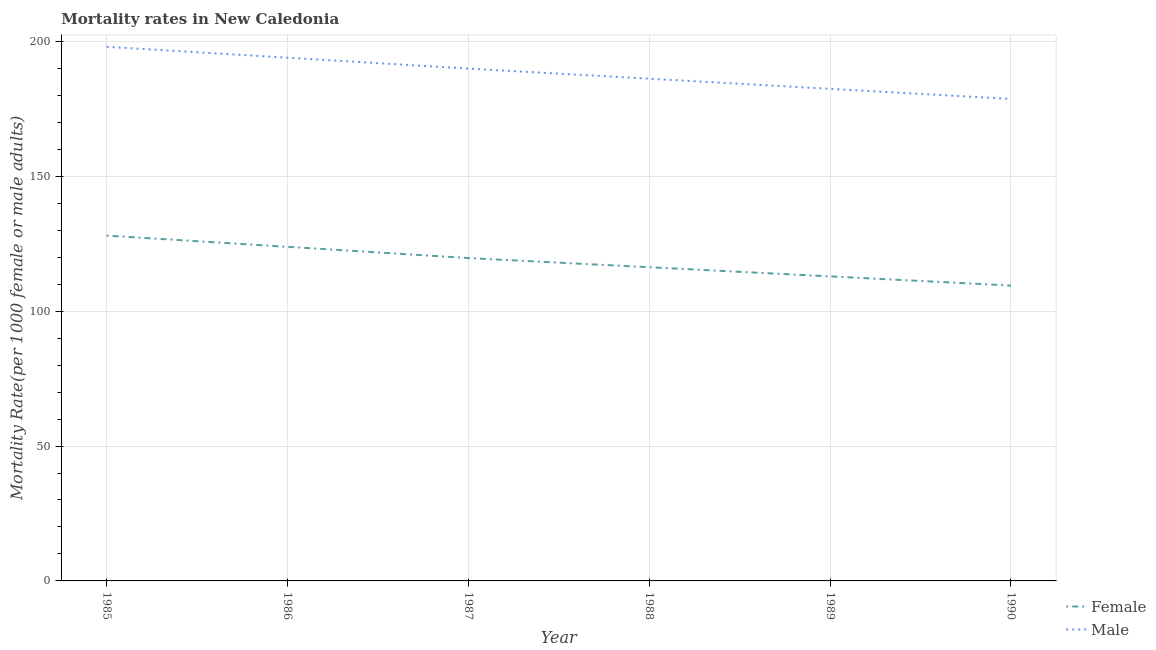What is the female mortality rate in 1990?
Give a very brief answer. 109.49. Across all years, what is the maximum male mortality rate?
Your answer should be compact. 198. Across all years, what is the minimum male mortality rate?
Make the answer very short. 178.67. In which year was the male mortality rate maximum?
Offer a terse response. 1985. What is the total female mortality rate in the graph?
Your answer should be very brief. 710.22. What is the difference between the female mortality rate in 1989 and that in 1990?
Your answer should be compact. 3.4. What is the difference between the male mortality rate in 1985 and the female mortality rate in 1986?
Your answer should be very brief. 74.14. What is the average female mortality rate per year?
Provide a short and direct response. 118.37. In the year 1989, what is the difference between the male mortality rate and female mortality rate?
Your answer should be very brief. 69.53. In how many years, is the female mortality rate greater than 190?
Provide a short and direct response. 0. What is the ratio of the female mortality rate in 1985 to that in 1986?
Make the answer very short. 1.03. Is the difference between the female mortality rate in 1987 and 1990 greater than the difference between the male mortality rate in 1987 and 1990?
Give a very brief answer. No. What is the difference between the highest and the second highest male mortality rate?
Your answer should be very brief. 4.04. What is the difference between the highest and the lowest female mortality rate?
Your response must be concise. 18.53. Is the female mortality rate strictly greater than the male mortality rate over the years?
Offer a terse response. No. Is the female mortality rate strictly less than the male mortality rate over the years?
Your answer should be very brief. Yes. What is the difference between two consecutive major ticks on the Y-axis?
Your answer should be very brief. 50. Where does the legend appear in the graph?
Offer a very short reply. Bottom right. How many legend labels are there?
Offer a very short reply. 2. How are the legend labels stacked?
Offer a terse response. Vertical. What is the title of the graph?
Your answer should be very brief. Mortality rates in New Caledonia. What is the label or title of the Y-axis?
Keep it short and to the point. Mortality Rate(per 1000 female or male adults). What is the Mortality Rate(per 1000 female or male adults) of Female in 1985?
Your answer should be compact. 128.02. What is the Mortality Rate(per 1000 female or male adults) in Male in 1985?
Give a very brief answer. 198. What is the Mortality Rate(per 1000 female or male adults) in Female in 1986?
Keep it short and to the point. 123.85. What is the Mortality Rate(per 1000 female or male adults) in Male in 1986?
Provide a succinct answer. 193.96. What is the Mortality Rate(per 1000 female or male adults) of Female in 1987?
Your response must be concise. 119.69. What is the Mortality Rate(per 1000 female or male adults) in Male in 1987?
Your answer should be very brief. 189.92. What is the Mortality Rate(per 1000 female or male adults) of Female in 1988?
Offer a terse response. 116.29. What is the Mortality Rate(per 1000 female or male adults) in Male in 1988?
Give a very brief answer. 186.17. What is the Mortality Rate(per 1000 female or male adults) of Female in 1989?
Your answer should be compact. 112.89. What is the Mortality Rate(per 1000 female or male adults) in Male in 1989?
Offer a terse response. 182.42. What is the Mortality Rate(per 1000 female or male adults) in Female in 1990?
Provide a short and direct response. 109.49. What is the Mortality Rate(per 1000 female or male adults) of Male in 1990?
Your response must be concise. 178.67. Across all years, what is the maximum Mortality Rate(per 1000 female or male adults) in Female?
Ensure brevity in your answer.  128.02. Across all years, what is the maximum Mortality Rate(per 1000 female or male adults) of Male?
Make the answer very short. 198. Across all years, what is the minimum Mortality Rate(per 1000 female or male adults) of Female?
Make the answer very short. 109.49. Across all years, what is the minimum Mortality Rate(per 1000 female or male adults) in Male?
Offer a terse response. 178.67. What is the total Mortality Rate(per 1000 female or male adults) in Female in the graph?
Give a very brief answer. 710.22. What is the total Mortality Rate(per 1000 female or male adults) in Male in the graph?
Provide a short and direct response. 1129.14. What is the difference between the Mortality Rate(per 1000 female or male adults) in Female in 1985 and that in 1986?
Make the answer very short. 4.17. What is the difference between the Mortality Rate(per 1000 female or male adults) of Male in 1985 and that in 1986?
Offer a terse response. 4.04. What is the difference between the Mortality Rate(per 1000 female or male adults) in Female in 1985 and that in 1987?
Provide a succinct answer. 8.33. What is the difference between the Mortality Rate(per 1000 female or male adults) in Male in 1985 and that in 1987?
Your answer should be compact. 8.07. What is the difference between the Mortality Rate(per 1000 female or male adults) of Female in 1985 and that in 1988?
Provide a short and direct response. 11.73. What is the difference between the Mortality Rate(per 1000 female or male adults) of Male in 1985 and that in 1988?
Ensure brevity in your answer.  11.82. What is the difference between the Mortality Rate(per 1000 female or male adults) of Female in 1985 and that in 1989?
Offer a terse response. 15.13. What is the difference between the Mortality Rate(per 1000 female or male adults) in Male in 1985 and that in 1989?
Your answer should be very brief. 15.58. What is the difference between the Mortality Rate(per 1000 female or male adults) of Female in 1985 and that in 1990?
Your response must be concise. 18.53. What is the difference between the Mortality Rate(per 1000 female or male adults) in Male in 1985 and that in 1990?
Give a very brief answer. 19.33. What is the difference between the Mortality Rate(per 1000 female or male adults) of Female in 1986 and that in 1987?
Offer a very short reply. 4.17. What is the difference between the Mortality Rate(per 1000 female or male adults) of Male in 1986 and that in 1987?
Offer a very short reply. 4.04. What is the difference between the Mortality Rate(per 1000 female or male adults) in Female in 1986 and that in 1988?
Offer a terse response. 7.56. What is the difference between the Mortality Rate(per 1000 female or male adults) of Male in 1986 and that in 1988?
Provide a short and direct response. 7.79. What is the difference between the Mortality Rate(per 1000 female or male adults) in Female in 1986 and that in 1989?
Your answer should be very brief. 10.96. What is the difference between the Mortality Rate(per 1000 female or male adults) in Male in 1986 and that in 1989?
Offer a terse response. 11.54. What is the difference between the Mortality Rate(per 1000 female or male adults) of Female in 1986 and that in 1990?
Provide a succinct answer. 14.36. What is the difference between the Mortality Rate(per 1000 female or male adults) in Male in 1986 and that in 1990?
Ensure brevity in your answer.  15.29. What is the difference between the Mortality Rate(per 1000 female or male adults) in Female in 1987 and that in 1988?
Your answer should be compact. 3.4. What is the difference between the Mortality Rate(per 1000 female or male adults) in Male in 1987 and that in 1988?
Your response must be concise. 3.75. What is the difference between the Mortality Rate(per 1000 female or male adults) of Female in 1987 and that in 1989?
Offer a terse response. 6.8. What is the difference between the Mortality Rate(per 1000 female or male adults) of Male in 1987 and that in 1989?
Provide a short and direct response. 7.5. What is the difference between the Mortality Rate(per 1000 female or male adults) of Female in 1987 and that in 1990?
Make the answer very short. 10.19. What is the difference between the Mortality Rate(per 1000 female or male adults) in Male in 1987 and that in 1990?
Your answer should be very brief. 11.26. What is the difference between the Mortality Rate(per 1000 female or male adults) of Female in 1988 and that in 1989?
Offer a very short reply. 3.4. What is the difference between the Mortality Rate(per 1000 female or male adults) of Male in 1988 and that in 1989?
Your answer should be very brief. 3.75. What is the difference between the Mortality Rate(per 1000 female or male adults) of Female in 1988 and that in 1990?
Ensure brevity in your answer.  6.8. What is the difference between the Mortality Rate(per 1000 female or male adults) of Male in 1988 and that in 1990?
Your answer should be compact. 7.5. What is the difference between the Mortality Rate(per 1000 female or male adults) in Female in 1989 and that in 1990?
Your answer should be compact. 3.4. What is the difference between the Mortality Rate(per 1000 female or male adults) in Male in 1989 and that in 1990?
Give a very brief answer. 3.75. What is the difference between the Mortality Rate(per 1000 female or male adults) of Female in 1985 and the Mortality Rate(per 1000 female or male adults) of Male in 1986?
Your response must be concise. -65.94. What is the difference between the Mortality Rate(per 1000 female or male adults) in Female in 1985 and the Mortality Rate(per 1000 female or male adults) in Male in 1987?
Offer a terse response. -61.91. What is the difference between the Mortality Rate(per 1000 female or male adults) in Female in 1985 and the Mortality Rate(per 1000 female or male adults) in Male in 1988?
Provide a short and direct response. -58.15. What is the difference between the Mortality Rate(per 1000 female or male adults) of Female in 1985 and the Mortality Rate(per 1000 female or male adults) of Male in 1989?
Your answer should be compact. -54.4. What is the difference between the Mortality Rate(per 1000 female or male adults) of Female in 1985 and the Mortality Rate(per 1000 female or male adults) of Male in 1990?
Make the answer very short. -50.65. What is the difference between the Mortality Rate(per 1000 female or male adults) of Female in 1986 and the Mortality Rate(per 1000 female or male adults) of Male in 1987?
Offer a very short reply. -66.07. What is the difference between the Mortality Rate(per 1000 female or male adults) in Female in 1986 and the Mortality Rate(per 1000 female or male adults) in Male in 1988?
Your response must be concise. -62.32. What is the difference between the Mortality Rate(per 1000 female or male adults) of Female in 1986 and the Mortality Rate(per 1000 female or male adults) of Male in 1989?
Your response must be concise. -58.57. What is the difference between the Mortality Rate(per 1000 female or male adults) of Female in 1986 and the Mortality Rate(per 1000 female or male adults) of Male in 1990?
Provide a succinct answer. -54.82. What is the difference between the Mortality Rate(per 1000 female or male adults) in Female in 1987 and the Mortality Rate(per 1000 female or male adults) in Male in 1988?
Ensure brevity in your answer.  -66.49. What is the difference between the Mortality Rate(per 1000 female or male adults) in Female in 1987 and the Mortality Rate(per 1000 female or male adults) in Male in 1989?
Your answer should be compact. -62.73. What is the difference between the Mortality Rate(per 1000 female or male adults) of Female in 1987 and the Mortality Rate(per 1000 female or male adults) of Male in 1990?
Offer a terse response. -58.98. What is the difference between the Mortality Rate(per 1000 female or male adults) of Female in 1988 and the Mortality Rate(per 1000 female or male adults) of Male in 1989?
Give a very brief answer. -66.13. What is the difference between the Mortality Rate(per 1000 female or male adults) in Female in 1988 and the Mortality Rate(per 1000 female or male adults) in Male in 1990?
Provide a succinct answer. -62.38. What is the difference between the Mortality Rate(per 1000 female or male adults) of Female in 1989 and the Mortality Rate(per 1000 female or male adults) of Male in 1990?
Give a very brief answer. -65.78. What is the average Mortality Rate(per 1000 female or male adults) of Female per year?
Provide a short and direct response. 118.37. What is the average Mortality Rate(per 1000 female or male adults) of Male per year?
Give a very brief answer. 188.19. In the year 1985, what is the difference between the Mortality Rate(per 1000 female or male adults) of Female and Mortality Rate(per 1000 female or male adults) of Male?
Offer a very short reply. -69.98. In the year 1986, what is the difference between the Mortality Rate(per 1000 female or male adults) of Female and Mortality Rate(per 1000 female or male adults) of Male?
Your answer should be compact. -70.11. In the year 1987, what is the difference between the Mortality Rate(per 1000 female or male adults) of Female and Mortality Rate(per 1000 female or male adults) of Male?
Your response must be concise. -70.24. In the year 1988, what is the difference between the Mortality Rate(per 1000 female or male adults) in Female and Mortality Rate(per 1000 female or male adults) in Male?
Provide a short and direct response. -69.88. In the year 1989, what is the difference between the Mortality Rate(per 1000 female or male adults) in Female and Mortality Rate(per 1000 female or male adults) in Male?
Keep it short and to the point. -69.53. In the year 1990, what is the difference between the Mortality Rate(per 1000 female or male adults) in Female and Mortality Rate(per 1000 female or male adults) in Male?
Your response must be concise. -69.18. What is the ratio of the Mortality Rate(per 1000 female or male adults) in Female in 1985 to that in 1986?
Offer a terse response. 1.03. What is the ratio of the Mortality Rate(per 1000 female or male adults) of Male in 1985 to that in 1986?
Offer a terse response. 1.02. What is the ratio of the Mortality Rate(per 1000 female or male adults) of Female in 1985 to that in 1987?
Offer a very short reply. 1.07. What is the ratio of the Mortality Rate(per 1000 female or male adults) of Male in 1985 to that in 1987?
Offer a very short reply. 1.04. What is the ratio of the Mortality Rate(per 1000 female or male adults) of Female in 1985 to that in 1988?
Make the answer very short. 1.1. What is the ratio of the Mortality Rate(per 1000 female or male adults) in Male in 1985 to that in 1988?
Offer a terse response. 1.06. What is the ratio of the Mortality Rate(per 1000 female or male adults) in Female in 1985 to that in 1989?
Offer a terse response. 1.13. What is the ratio of the Mortality Rate(per 1000 female or male adults) of Male in 1985 to that in 1989?
Provide a short and direct response. 1.09. What is the ratio of the Mortality Rate(per 1000 female or male adults) of Female in 1985 to that in 1990?
Make the answer very short. 1.17. What is the ratio of the Mortality Rate(per 1000 female or male adults) in Male in 1985 to that in 1990?
Offer a very short reply. 1.11. What is the ratio of the Mortality Rate(per 1000 female or male adults) of Female in 1986 to that in 1987?
Provide a succinct answer. 1.03. What is the ratio of the Mortality Rate(per 1000 female or male adults) of Male in 1986 to that in 1987?
Your response must be concise. 1.02. What is the ratio of the Mortality Rate(per 1000 female or male adults) of Female in 1986 to that in 1988?
Make the answer very short. 1.06. What is the ratio of the Mortality Rate(per 1000 female or male adults) of Male in 1986 to that in 1988?
Your answer should be compact. 1.04. What is the ratio of the Mortality Rate(per 1000 female or male adults) in Female in 1986 to that in 1989?
Offer a very short reply. 1.1. What is the ratio of the Mortality Rate(per 1000 female or male adults) of Male in 1986 to that in 1989?
Ensure brevity in your answer.  1.06. What is the ratio of the Mortality Rate(per 1000 female or male adults) of Female in 1986 to that in 1990?
Provide a short and direct response. 1.13. What is the ratio of the Mortality Rate(per 1000 female or male adults) of Male in 1986 to that in 1990?
Keep it short and to the point. 1.09. What is the ratio of the Mortality Rate(per 1000 female or male adults) of Female in 1987 to that in 1988?
Make the answer very short. 1.03. What is the ratio of the Mortality Rate(per 1000 female or male adults) in Male in 1987 to that in 1988?
Make the answer very short. 1.02. What is the ratio of the Mortality Rate(per 1000 female or male adults) in Female in 1987 to that in 1989?
Make the answer very short. 1.06. What is the ratio of the Mortality Rate(per 1000 female or male adults) of Male in 1987 to that in 1989?
Give a very brief answer. 1.04. What is the ratio of the Mortality Rate(per 1000 female or male adults) in Female in 1987 to that in 1990?
Provide a short and direct response. 1.09. What is the ratio of the Mortality Rate(per 1000 female or male adults) of Male in 1987 to that in 1990?
Your answer should be very brief. 1.06. What is the ratio of the Mortality Rate(per 1000 female or male adults) of Female in 1988 to that in 1989?
Ensure brevity in your answer.  1.03. What is the ratio of the Mortality Rate(per 1000 female or male adults) in Male in 1988 to that in 1989?
Provide a short and direct response. 1.02. What is the ratio of the Mortality Rate(per 1000 female or male adults) of Female in 1988 to that in 1990?
Provide a succinct answer. 1.06. What is the ratio of the Mortality Rate(per 1000 female or male adults) of Male in 1988 to that in 1990?
Your response must be concise. 1.04. What is the ratio of the Mortality Rate(per 1000 female or male adults) in Female in 1989 to that in 1990?
Keep it short and to the point. 1.03. What is the difference between the highest and the second highest Mortality Rate(per 1000 female or male adults) of Female?
Provide a succinct answer. 4.17. What is the difference between the highest and the second highest Mortality Rate(per 1000 female or male adults) of Male?
Offer a terse response. 4.04. What is the difference between the highest and the lowest Mortality Rate(per 1000 female or male adults) of Female?
Provide a short and direct response. 18.53. What is the difference between the highest and the lowest Mortality Rate(per 1000 female or male adults) of Male?
Give a very brief answer. 19.33. 